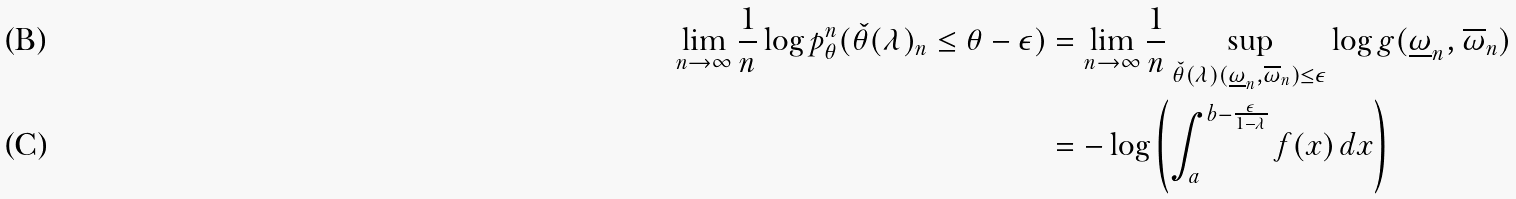<formula> <loc_0><loc_0><loc_500><loc_500>\lim _ { n \to \infty } \frac { 1 } { n } \log p ^ { n } _ { \theta } ( \check { \theta } ( \lambda ) _ { n } \leq \theta - \epsilon ) & = \lim _ { n \to \infty } \frac { 1 } { n } \sup _ { \check { \theta } ( \lambda ) ( \underline { \omega } _ { n } , \overline { \omega } _ { n } ) \leq \epsilon } \log g ( \underline { \omega } _ { n } , \overline { \omega } _ { n } ) \\ & = - \log \left ( \int _ { a } ^ { b - \frac { \epsilon } { 1 - \lambda } } f ( x ) \, d x \right )</formula> 